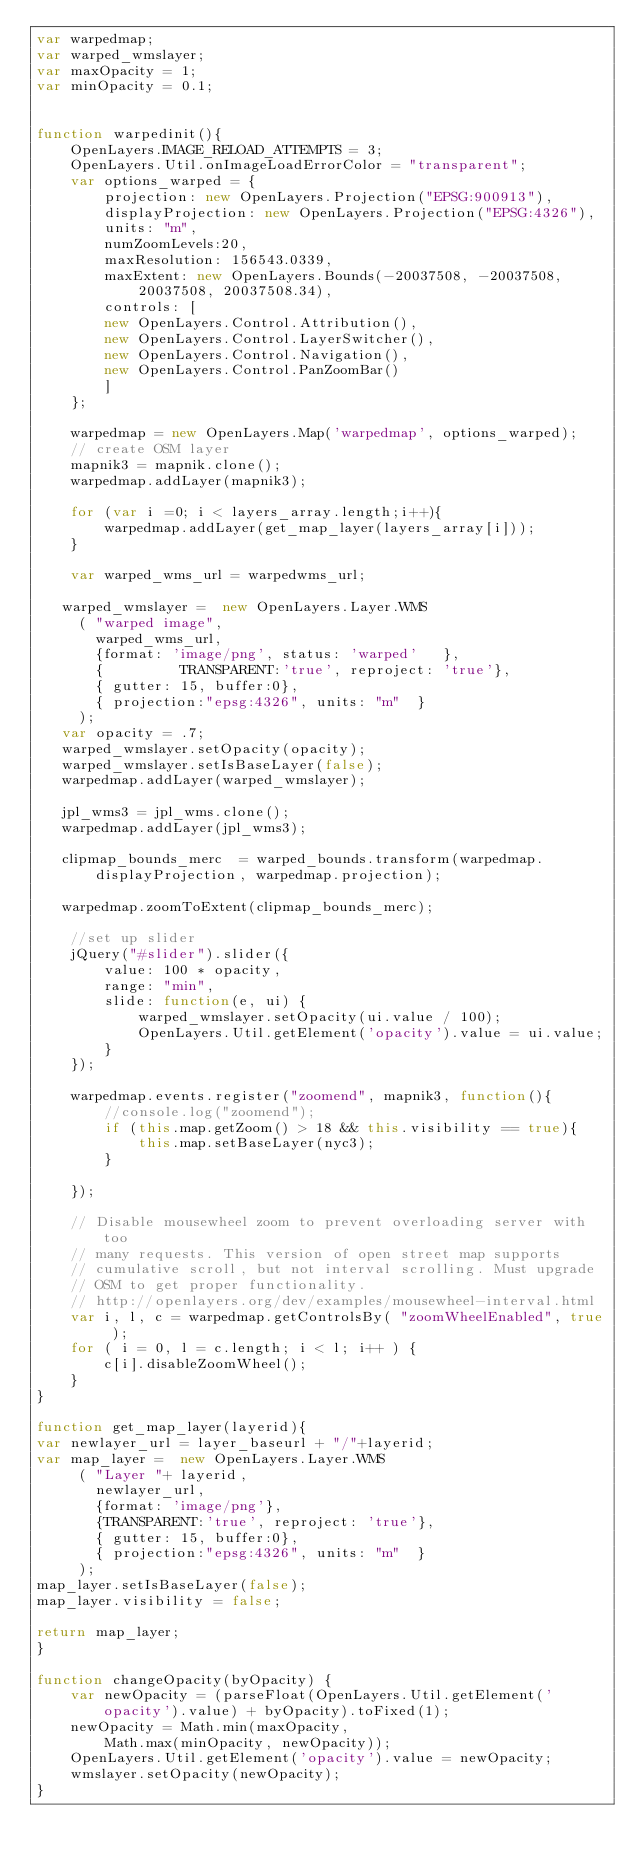Convert code to text. <code><loc_0><loc_0><loc_500><loc_500><_JavaScript_>var warpedmap;
var warped_wmslayer;
var maxOpacity = 1;
var minOpacity = 0.1;


function warpedinit(){
    OpenLayers.IMAGE_RELOAD_ATTEMPTS = 3;
    OpenLayers.Util.onImageLoadErrorColor = "transparent";
    var options_warped = {
        projection: new OpenLayers.Projection("EPSG:900913"),
        displayProjection: new OpenLayers.Projection("EPSG:4326"),
        units: "m",
        numZoomLevels:20,
        maxResolution: 156543.0339,
        maxExtent: new OpenLayers.Bounds(-20037508, -20037508,
            20037508, 20037508.34),
        controls: [
        new OpenLayers.Control.Attribution(),
        new OpenLayers.Control.LayerSwitcher(),
        new OpenLayers.Control.Navigation(),
        new OpenLayers.Control.PanZoomBar()
        ]
    };

    warpedmap = new OpenLayers.Map('warpedmap', options_warped);
    // create OSM layer
    mapnik3 = mapnik.clone();
    warpedmap.addLayer(mapnik3);

    for (var i =0; i < layers_array.length;i++){
        warpedmap.addLayer(get_map_layer(layers_array[i]));
    }

    var warped_wms_url = warpedwms_url;

   warped_wmslayer =  new OpenLayers.Layer.WMS
     ( "warped image",
       warped_wms_url,
       {format: 'image/png', status: 'warped'   },
       {         TRANSPARENT:'true', reproject: 'true'},
       { gutter: 15, buffer:0},
       { projection:"epsg:4326", units: "m"  }
     );
   var opacity = .7;
   warped_wmslayer.setOpacity(opacity);
   warped_wmslayer.setIsBaseLayer(false);
   warpedmap.addLayer(warped_wmslayer);

   jpl_wms3 = jpl_wms.clone();
   warpedmap.addLayer(jpl_wms3);

   clipmap_bounds_merc  = warped_bounds.transform(warpedmap.displayProjection, warpedmap.projection);

   warpedmap.zoomToExtent(clipmap_bounds_merc);

    //set up slider
    jQuery("#slider").slider({
        value: 100 * opacity,
        range: "min",
        slide: function(e, ui) {
            warped_wmslayer.setOpacity(ui.value / 100);
            OpenLayers.Util.getElement('opacity').value = ui.value;
        }
    });

    warpedmap.events.register("zoomend", mapnik3, function(){
        //console.log("zoomend");
        if (this.map.getZoom() > 18 && this.visibility == true){
            this.map.setBaseLayer(nyc3);
        }

    });

    // Disable mousewheel zoom to prevent overloading server with too
    // many requests. This version of open street map supports
    // cumulative scroll, but not interval scrolling. Must upgrade
    // OSM to get proper functionality.
    // http://openlayers.org/dev/examples/mousewheel-interval.html
    var i, l, c = warpedmap.getControlsBy( "zoomWheelEnabled", true );
    for ( i = 0, l = c.length; i < l; i++ ) {
        c[i].disableZoomWheel();
    }
}

function get_map_layer(layerid){
var newlayer_url = layer_baseurl + "/"+layerid;
var map_layer =  new OpenLayers.Layer.WMS
     ( "Layer "+ layerid,
       newlayer_url,
       {format: 'image/png'},
       {TRANSPARENT:'true', reproject: 'true'},
       { gutter: 15, buffer:0},
       { projection:"epsg:4326", units: "m"  }
     );
map_layer.setIsBaseLayer(false);
map_layer.visibility = false;

return map_layer;
}

function changeOpacity(byOpacity) {
    var newOpacity = (parseFloat(OpenLayers.Util.getElement('opacity').value) + byOpacity).toFixed(1);
    newOpacity = Math.min(maxOpacity,
        Math.max(minOpacity, newOpacity));
    OpenLayers.Util.getElement('opacity').value = newOpacity;
    wmslayer.setOpacity(newOpacity);
}
</code> 